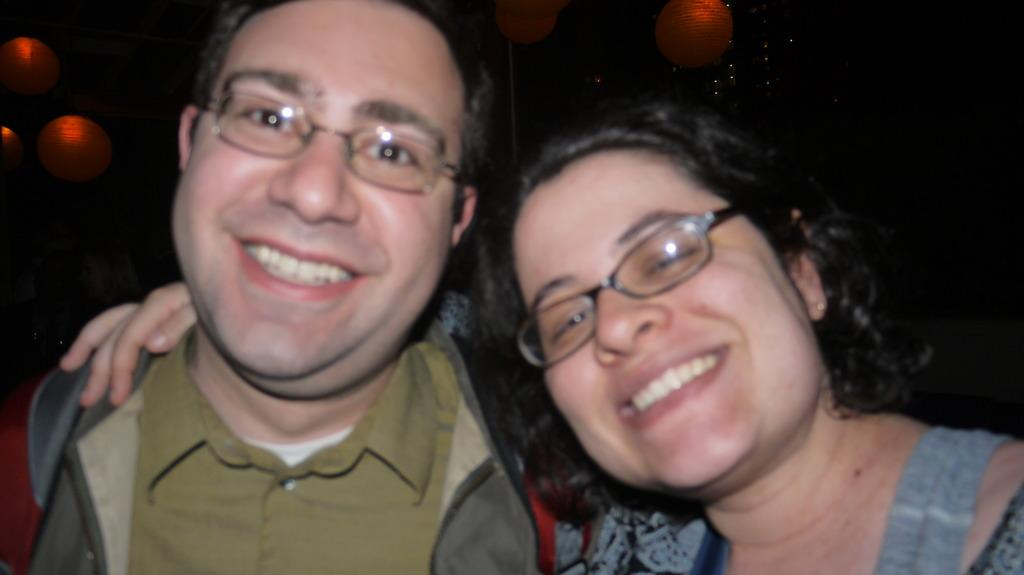How many people are in the image? There are two people in the image. What is the facial expression of the people in the image? The people are smiling. What are the people doing in the image? The people are posing for a photo. What can be seen in the background of the image? There are lights visible in the background of the image. What type of plantation is visible in the image? There is no plantation present in the image. What type of hospital can be seen in the background of the image? There is no hospital present in the image. 